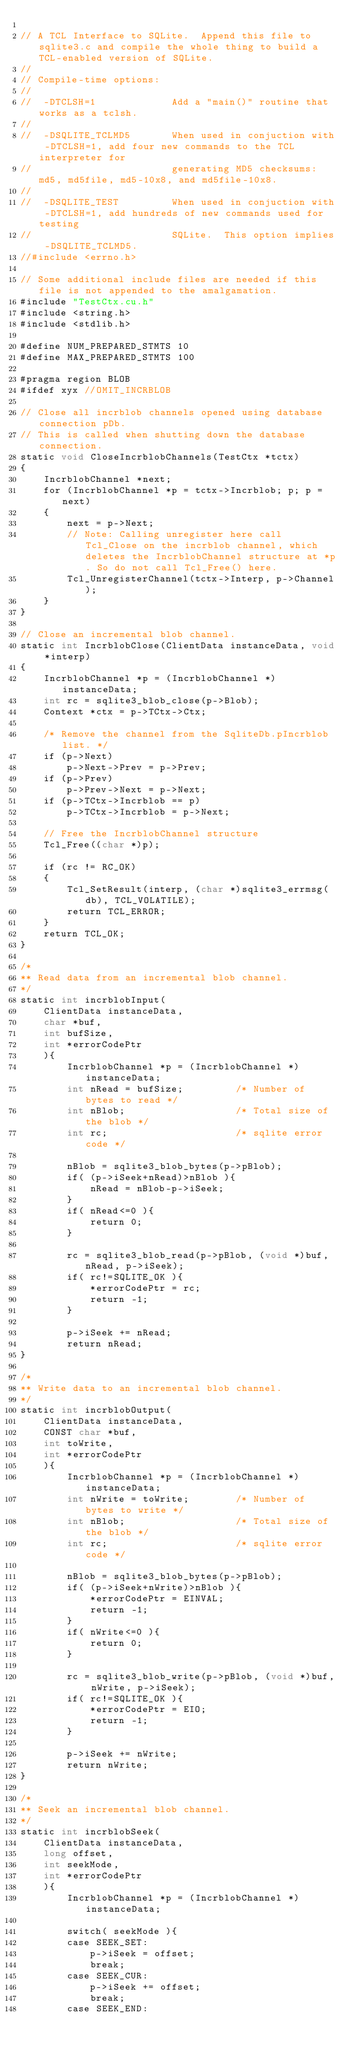Convert code to text. <code><loc_0><loc_0><loc_500><loc_500><_Cuda_>
// A TCL Interface to SQLite.  Append this file to sqlite3.c and compile the whole thing to build a TCL-enabled version of SQLite.
//
// Compile-time options:
//
//  -DTCLSH=1             Add a "main()" routine that works as a tclsh.
//
//  -DSQLITE_TCLMD5       When used in conjuction with -DTCLSH=1, add four new commands to the TCL interpreter for
//                        generating MD5 checksums:  md5, md5file, md5-10x8, and md5file-10x8.
//
//  -DSQLITE_TEST         When used in conjuction with -DTCLSH=1, add hundreds of new commands used for testing
//                        SQLite.  This option implies -DSQLITE_TCLMD5.
//#include <errno.h>

// Some additional include files are needed if this file is not appended to the amalgamation.
#include "TestCtx.cu.h"
#include <string.h>
#include <stdlib.h>

#define NUM_PREPARED_STMTS 10
#define MAX_PREPARED_STMTS 100

#pragma region BLOB
#ifdef xyx //OMIT_INCRBLOB

// Close all incrblob channels opened using database connection pDb.
// This is called when shutting down the database connection.
static void CloseIncrblobChannels(TestCtx *tctx)
{
	IncrblobChannel *next;
	for (IncrblobChannel *p = tctx->Incrblob; p; p = next)
	{
		next = p->Next;
		// Note: Calling unregister here call Tcl_Close on the incrblob channel, which deletes the IncrblobChannel structure at *p. So do not call Tcl_Free() here.
		Tcl_UnregisterChannel(tctx->Interp, p->Channel);
	}
}

// Close an incremental blob channel.
static int IncrblobClose(ClientData instanceData, void *interp)
{
	IncrblobChannel *p = (IncrblobChannel *)instanceData;
	int rc = sqlite3_blob_close(p->Blob);
	Context *ctx = p->TCtx->Ctx;

	/* Remove the channel from the SqliteDb.pIncrblob list. */
	if (p->Next)
		p->Next->Prev = p->Prev;
	if (p->Prev)
		p->Prev->Next = p->Next;
	if (p->TCtx->Incrblob == p)
		p->TCtx->Incrblob = p->Next;

	// Free the IncrblobChannel structure
	Tcl_Free((char *)p);

	if (rc != RC_OK)
	{
		Tcl_SetResult(interp, (char *)sqlite3_errmsg(db), TCL_VOLATILE);
		return TCL_ERROR;
	}
	return TCL_OK;
}

/*
** Read data from an incremental blob channel.
*/
static int incrblobInput(
	ClientData instanceData, 
	char *buf, 
	int bufSize,
	int *errorCodePtr
	){
		IncrblobChannel *p = (IncrblobChannel *)instanceData;
		int nRead = bufSize;         /* Number of bytes to read */
		int nBlob;                   /* Total size of the blob */
		int rc;                      /* sqlite error code */

		nBlob = sqlite3_blob_bytes(p->pBlob);
		if( (p->iSeek+nRead)>nBlob ){
			nRead = nBlob-p->iSeek;
		}
		if( nRead<=0 ){
			return 0;
		}

		rc = sqlite3_blob_read(p->pBlob, (void *)buf, nRead, p->iSeek);
		if( rc!=SQLITE_OK ){
			*errorCodePtr = rc;
			return -1;
		}

		p->iSeek += nRead;
		return nRead;
}

/*
** Write data to an incremental blob channel.
*/
static int incrblobOutput(
	ClientData instanceData, 
	CONST char *buf, 
	int toWrite,
	int *errorCodePtr
	){
		IncrblobChannel *p = (IncrblobChannel *)instanceData;
		int nWrite = toWrite;        /* Number of bytes to write */
		int nBlob;                   /* Total size of the blob */
		int rc;                      /* sqlite error code */

		nBlob = sqlite3_blob_bytes(p->pBlob);
		if( (p->iSeek+nWrite)>nBlob ){
			*errorCodePtr = EINVAL;
			return -1;
		}
		if( nWrite<=0 ){
			return 0;
		}

		rc = sqlite3_blob_write(p->pBlob, (void *)buf, nWrite, p->iSeek);
		if( rc!=SQLITE_OK ){
			*errorCodePtr = EIO;
			return -1;
		}

		p->iSeek += nWrite;
		return nWrite;
}

/*
** Seek an incremental blob channel.
*/
static int incrblobSeek(
	ClientData instanceData, 
	long offset,
	int seekMode,
	int *errorCodePtr
	){
		IncrblobChannel *p = (IncrblobChannel *)instanceData;

		switch( seekMode ){
		case SEEK_SET:
			p->iSeek = offset;
			break;
		case SEEK_CUR:
			p->iSeek += offset;
			break;
		case SEEK_END:</code> 